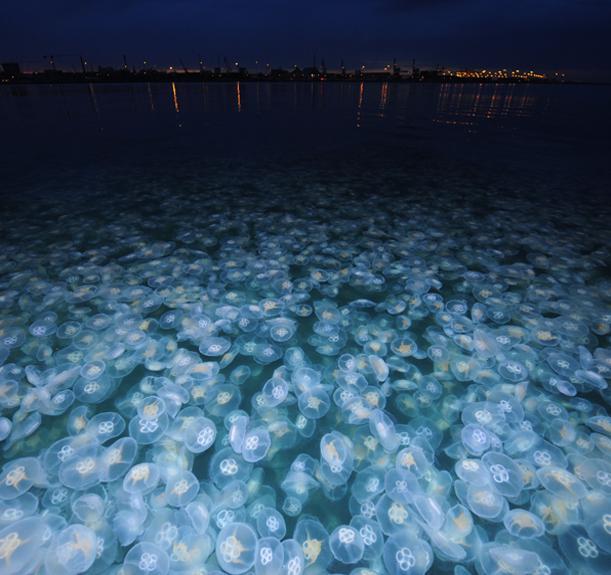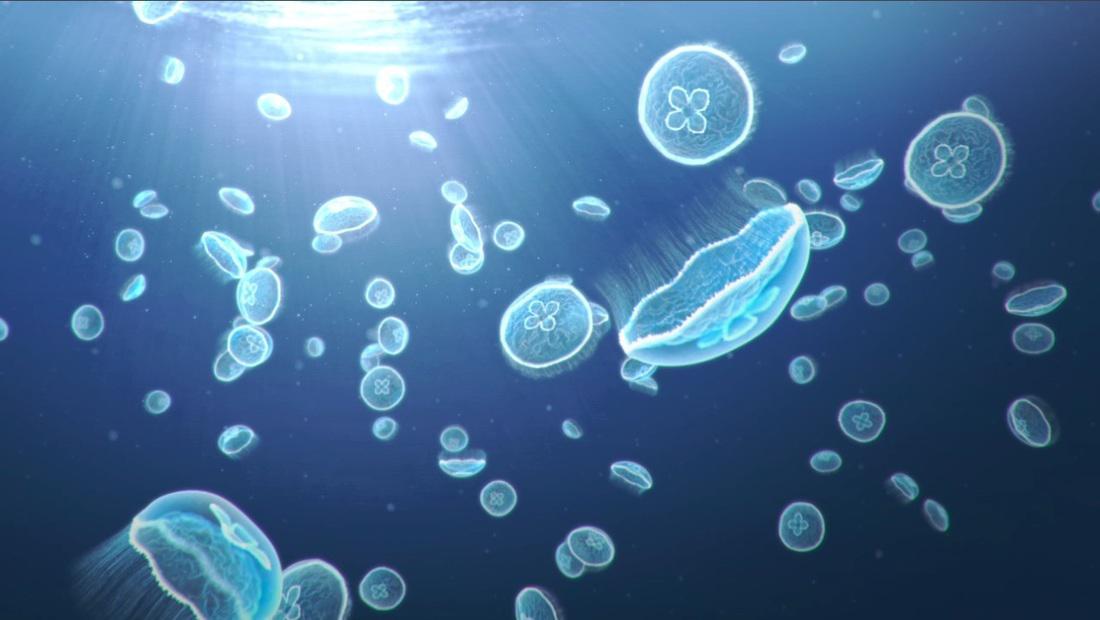The first image is the image on the left, the second image is the image on the right. For the images shown, is this caption "there are many jellyfish being viewed from above water in daylight hours" true? Answer yes or no. No. The first image is the image on the left, the second image is the image on the right. Evaluate the accuracy of this statement regarding the images: "The left image shows masses of light blue jellyfish viewed from above the water's surface, with a city horizon in the background.". Is it true? Answer yes or no. Yes. 